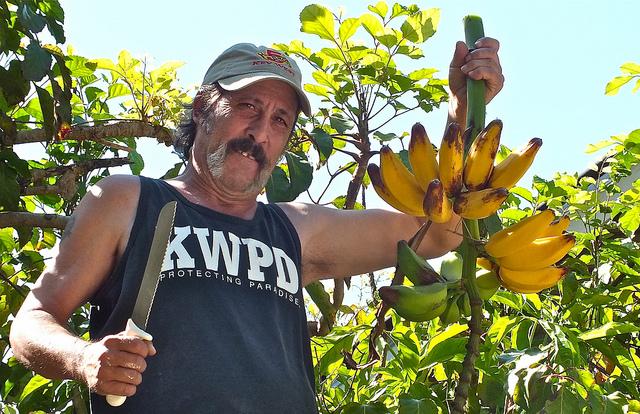What is written on the man's shirt?
Be succinct. Kwpd. What is protecting paradise?
Quick response, please. Kwpd. What sort of tool is the man holding?
Give a very brief answer. Knife. 